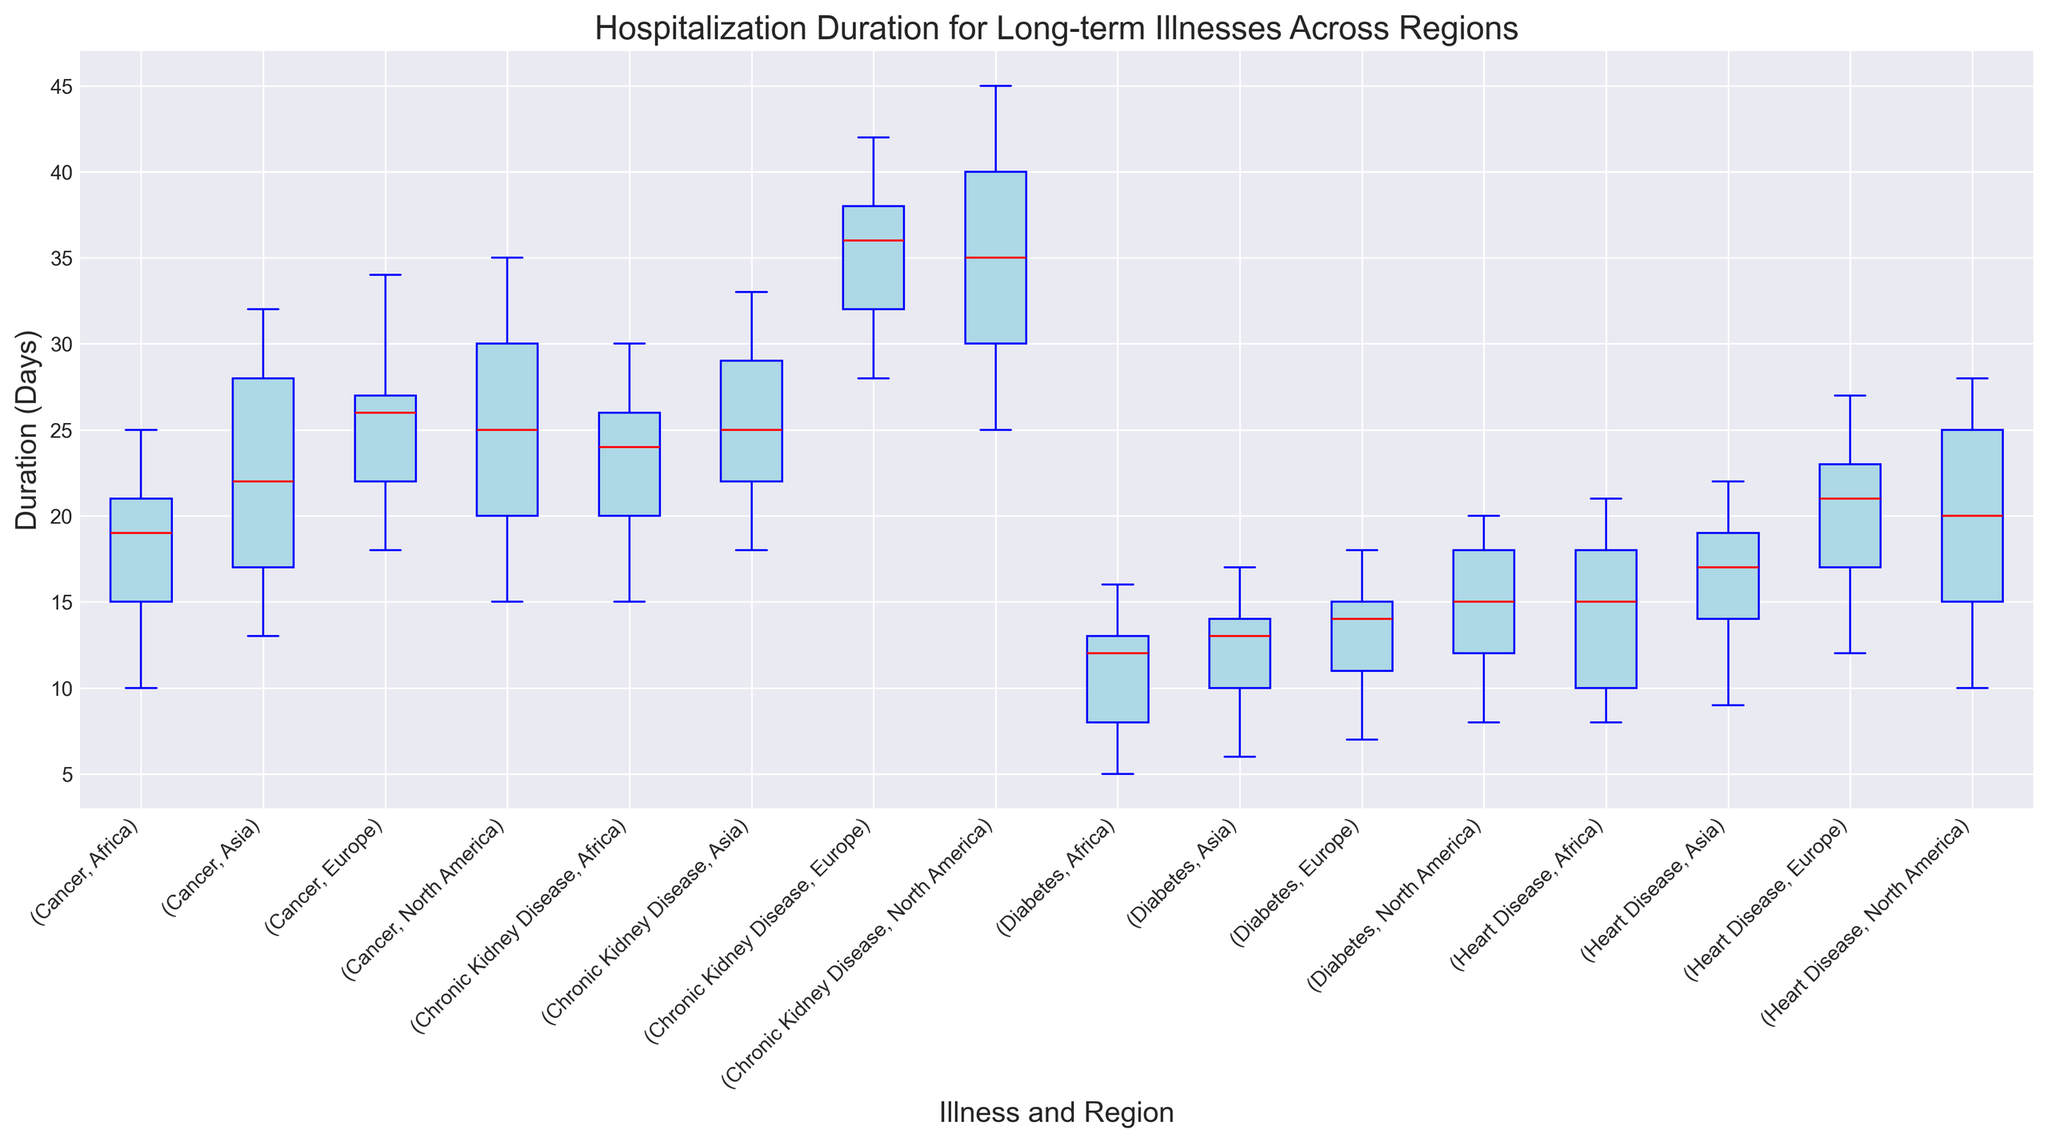Which illness has the highest median hospitalization duration in Africa? To find the illness with the highest median duration in Africa, look at the median lines (red) within the boxes corresponding to the 'Africa' region. For 'Cancer', 'Diabetes', 'Heart Disease', and 'Chronic Kidney Disease' in Africa, the highest median appears in the 'Chronic Kidney Disease' group.
Answer: Chronic Kidney Disease How does the median hospitalization duration for chronic kidney disease in North America compare to Europe? Compare the median lines (red) of 'Chronic Kidney Disease' in both North America and Europe. North America's median line is higher than Europe's median line.
Answer: North America is higher Which region has the smallest variation in hospitalization durations for diabetes? The variation is represented by the spread of the box. For Diabetes in North America, Europe, Asia, and Africa, the smallest spread (shortest box) is seen in 'Africa'.
Answer: Africa For heart disease, which regions show overlapping ranges of hospitalization durations? Overlapping ranges are indicated by overlapping boxes or whiskers. 'Heart Disease' in North America, Europe, and Asia show overlaps in their indicated ranges with each other. North America, Europe, and Asia boxes overlap on the plot.
Answer: North America, Europe, Asia What is the interquartile range (IQR) of hospitalization durations for cancer in Asia? The IQR is the difference between the third quartile (upper edge of the box) and the first quartile (lower edge of the box). For 'Cancer' in Asia, the upper quartile is around 28 and the lower quartile is around 17, making the IQR 28 - 17 = 11.
Answer: 11 Does diabetes in Europe have a higher median hospitalization duration than cancer in Africa? Compare the median lines (red) in 'Diabetes' for Europe and 'Cancer' in Africa. 'Diabetes' in Europe has a slightly higher median than 'Cancer' in Africa.
Answer: Yes What is the approximate range of hospitalization durations for heart disease in North America? The range is the difference between the maximum and minimum values, shown by the whiskers. For 'Heart Disease' in North America, the range goes from around 10 to 28.
Answer: 10 to 28 Which illness and region combination shows the highest overall hospitalization duration? Look for the whisker (the line extending from the top of the box) that reaches the highest. 'Chronic Kidney Disease' in North America shows the highest overall duration, with the whisker extending to around 45 days.
Answer: Chronic Kidney Disease in North America 